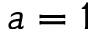<formula> <loc_0><loc_0><loc_500><loc_500>a = 1</formula> 